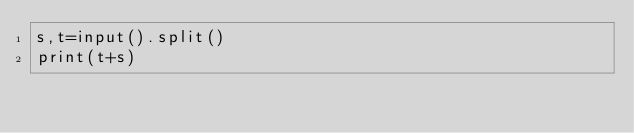Convert code to text. <code><loc_0><loc_0><loc_500><loc_500><_Cython_>s,t=input().split()
print(t+s)</code> 